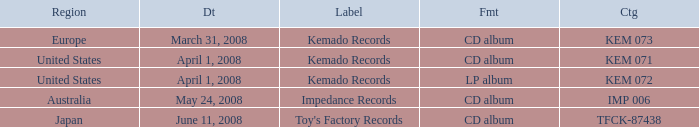Which Format has a Date of may 24, 2008? CD album. 